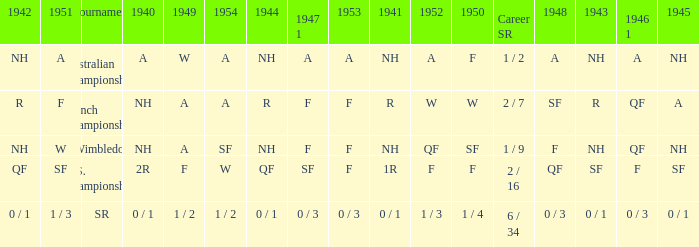What is the 1944 result for the U.S. Championships? QF. 